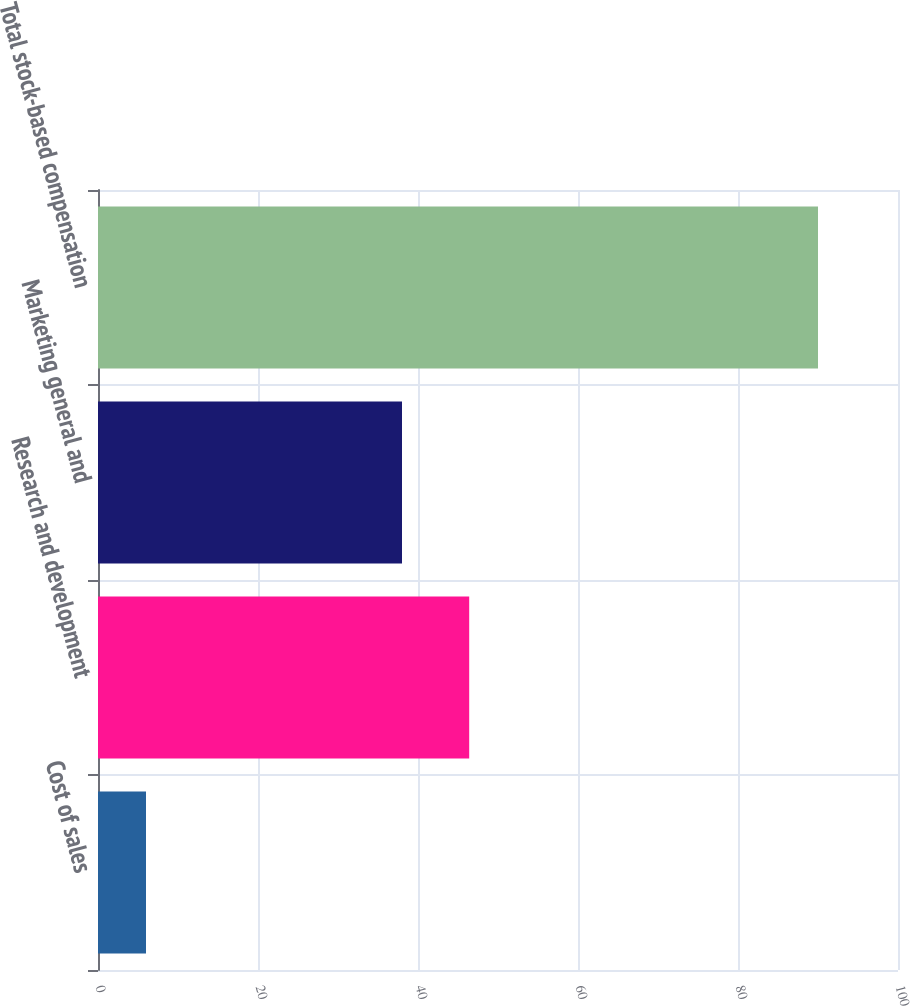Convert chart to OTSL. <chart><loc_0><loc_0><loc_500><loc_500><bar_chart><fcel>Cost of sales<fcel>Research and development<fcel>Marketing general and<fcel>Total stock-based compensation<nl><fcel>6<fcel>46.4<fcel>38<fcel>90<nl></chart> 